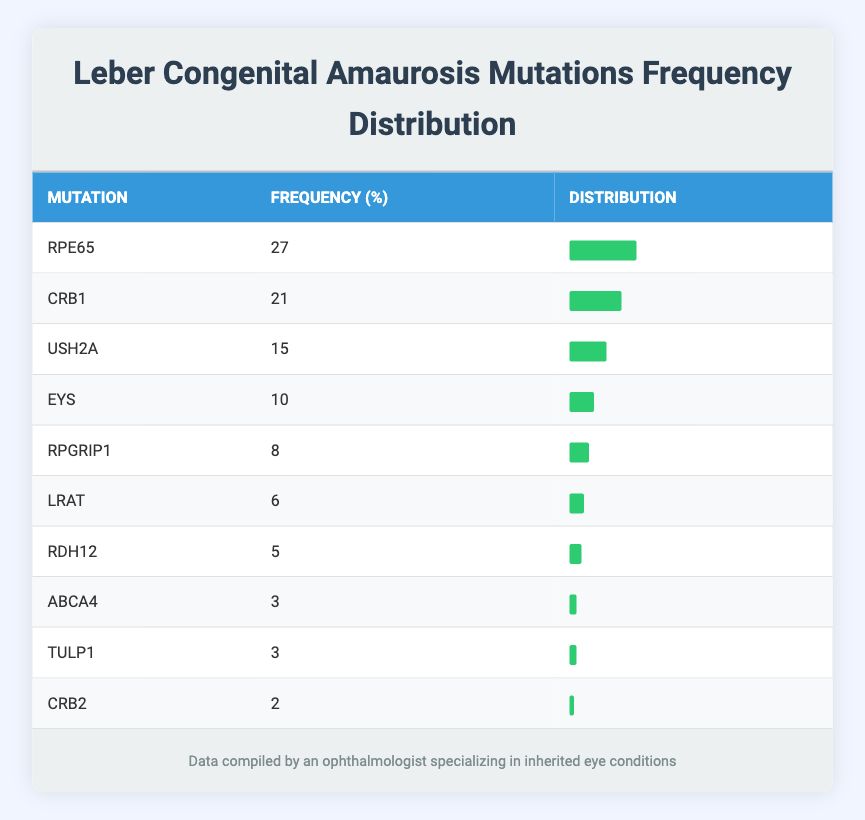What is the mutation with the highest frequency? The table lists the frequencies of different mutations. By scanning through the table, "RPE65" has the highest frequency at 27.
Answer: RPE65 How many mutations have a frequency of 3? Looking at the table, both "ABCA4" and "TULP1" have a frequency of 3. Therefore, the count of such mutations is 2.
Answer: 2 What is the total frequency of mutations listed in the table? To find the total frequency, we add all the individual frequencies: 27 + 21 + 15 + 10 + 8 + 6 + 5 + 3 + 3 + 2 = 100.
Answer: 100 Is "USH2A" more frequent than "EYS"? "USH2A" has a frequency of 15, while "EYS" has a frequency of 10. Since 15 is greater than 10, the statement is true.
Answer: Yes What percentage of mutations have a frequency less than 5? The mutations "RDH12," "ABCA4," "TULP1," and "CRB2" have frequencies of 5, 3, 3, and 2 respectively, totaling 4 mutations. There are 10 mutations in total. Calculate the percentage: (4/10) * 100 = 40%.
Answer: 40% What is the difference in frequency between the most and least common mutation? The most common mutation "RPE65" has a frequency of 27, while the least common mutation "CRB2" has a frequency of 2. The difference is 27 - 2 = 25.
Answer: 25 Which mutation has a frequency that is exactly 6 less than "CRB1"? "CRB1" has a frequency of 21; thus, we subtract 6 from this value: 21 - 6 = 15. "USH2A" has a frequency of 15.
Answer: USH2A How many mutations have a frequency greater than 10? Reviewing the table, the mutations with frequencies greater than 10 are "RPE65," "CRB1," "USH2A," and "EYS." So, there are 4 mutations with frequencies greater than 10.
Answer: 4 Is there a mutation with a frequency of 6? Checking the table, "LRAT" has a frequency of 6. Thus, there is indeed a mutation with this frequency.
Answer: Yes 